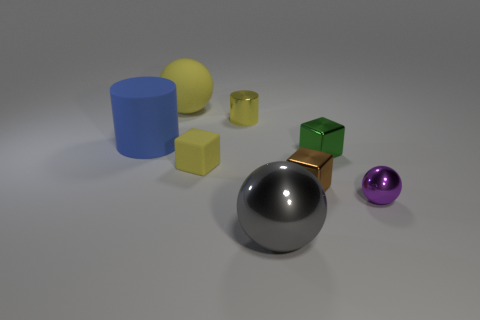Subtract all large gray balls. How many balls are left? 2 Add 2 small yellow cubes. How many objects exist? 10 Subtract all green spheres. Subtract all blue cylinders. How many spheres are left? 3 Add 8 yellow cylinders. How many yellow cylinders are left? 9 Add 6 cyan rubber spheres. How many cyan rubber spheres exist? 6 Subtract 1 gray spheres. How many objects are left? 7 Subtract all cylinders. How many objects are left? 6 Subtract all small yellow spheres. Subtract all green metallic blocks. How many objects are left? 7 